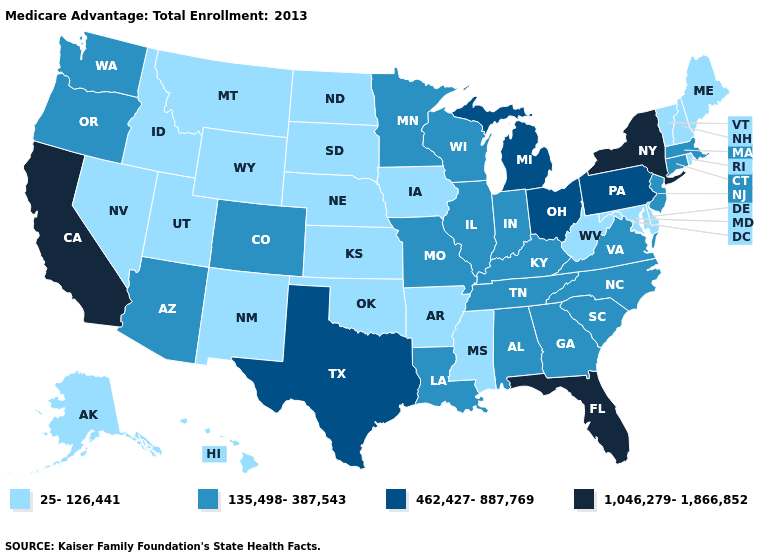Which states have the lowest value in the USA?
Write a very short answer. Alaska, Arkansas, Delaware, Hawaii, Iowa, Idaho, Kansas, Maryland, Maine, Mississippi, Montana, North Dakota, Nebraska, New Hampshire, New Mexico, Nevada, Oklahoma, Rhode Island, South Dakota, Utah, Vermont, West Virginia, Wyoming. Does Texas have the lowest value in the USA?
Quick response, please. No. What is the highest value in states that border New Jersey?
Concise answer only. 1,046,279-1,866,852. What is the lowest value in the USA?
Be succinct. 25-126,441. What is the value of Colorado?
Keep it brief. 135,498-387,543. Among the states that border Georgia , which have the highest value?
Concise answer only. Florida. Which states have the lowest value in the MidWest?
Answer briefly. Iowa, Kansas, North Dakota, Nebraska, South Dakota. Name the states that have a value in the range 1,046,279-1,866,852?
Write a very short answer. California, Florida, New York. What is the value of Idaho?
Write a very short answer. 25-126,441. Which states hav the highest value in the MidWest?
Be succinct. Michigan, Ohio. Is the legend a continuous bar?
Keep it brief. No. Name the states that have a value in the range 25-126,441?
Give a very brief answer. Alaska, Arkansas, Delaware, Hawaii, Iowa, Idaho, Kansas, Maryland, Maine, Mississippi, Montana, North Dakota, Nebraska, New Hampshire, New Mexico, Nevada, Oklahoma, Rhode Island, South Dakota, Utah, Vermont, West Virginia, Wyoming. What is the lowest value in the USA?
Be succinct. 25-126,441. What is the highest value in the South ?
Short answer required. 1,046,279-1,866,852. What is the lowest value in states that border Maryland?
Short answer required. 25-126,441. 